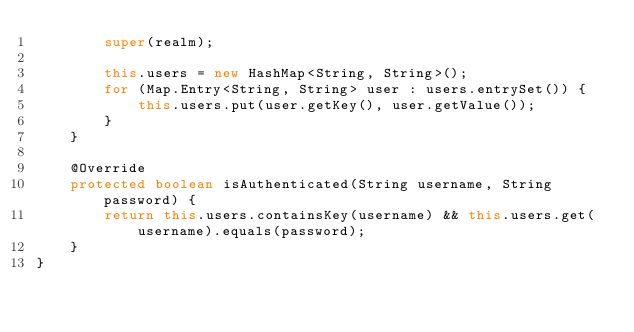Convert code to text. <code><loc_0><loc_0><loc_500><loc_500><_Java_>        super(realm);

        this.users = new HashMap<String, String>();
        for (Map.Entry<String, String> user : users.entrySet()) {
            this.users.put(user.getKey(), user.getValue());
        }
    }

    @Override
    protected boolean isAuthenticated(String username, String password) {
        return this.users.containsKey(username) && this.users.get(username).equals(password);
    }
}
</code> 